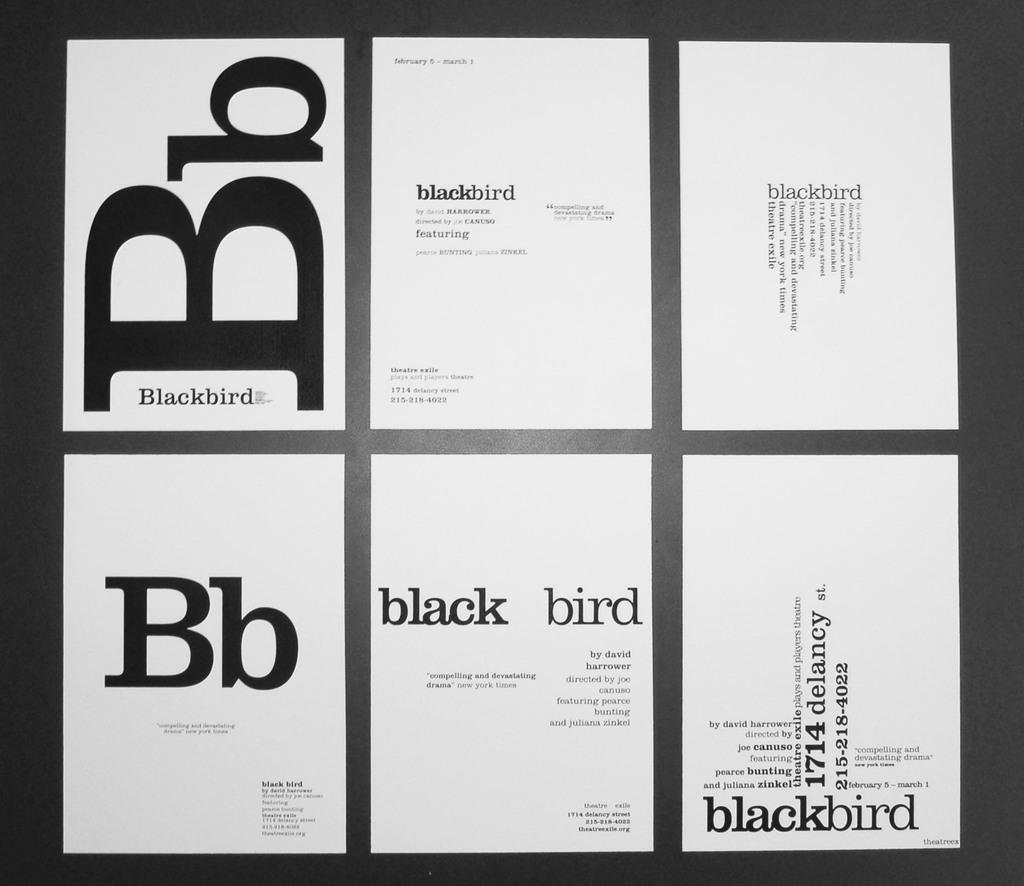Provide a one-sentence caption for the provided image. Six pages of white paper with black text on them highlighting the word Blackbird and its abbreviation. 